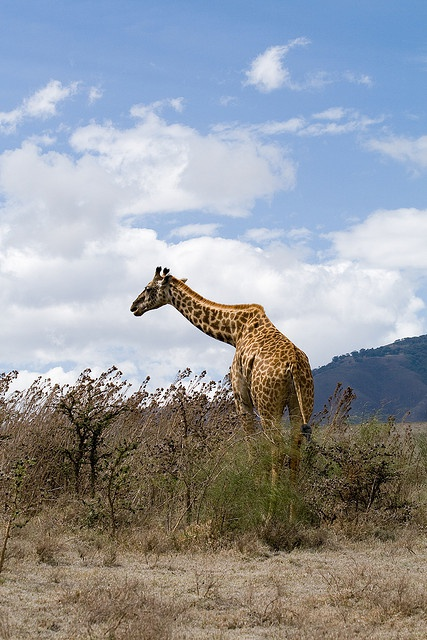Describe the objects in this image and their specific colors. I can see a giraffe in darkgray, olive, black, maroon, and gray tones in this image. 